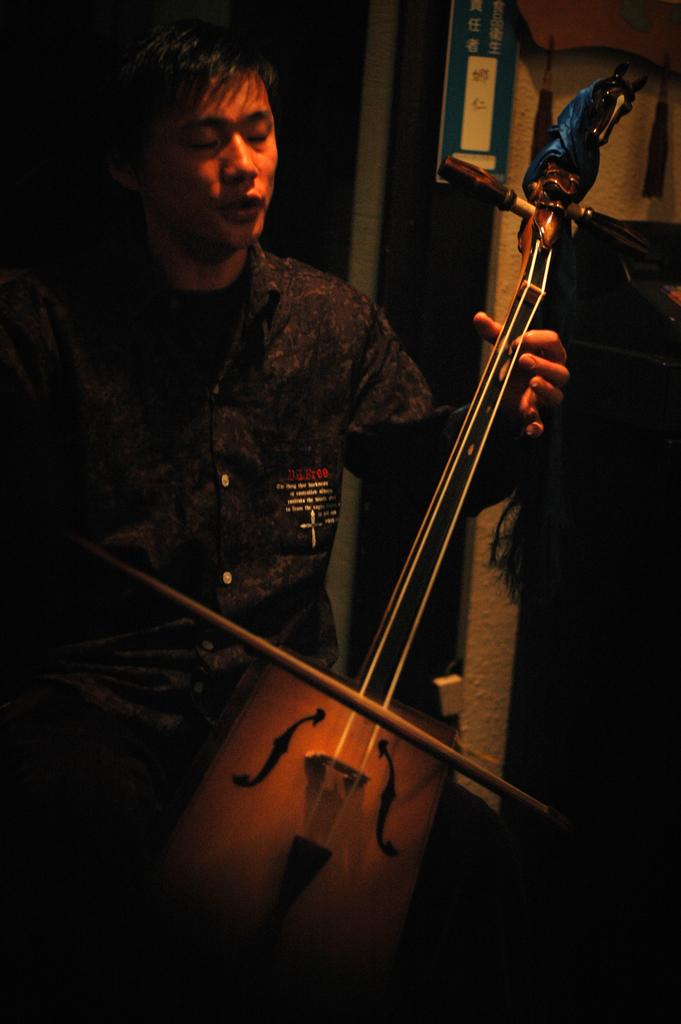What is the main activity being performed by the person in the image? The person in the image is playing a violin. What can be seen in the background of the image? There are posters and hangings in the background of the image. Can you describe the wooden shelf on the right side of the image? The wooden shelf is brown in color. What type of suit is the person wearing while playing the violin in the image? The image does not show the person wearing a suit; they are dressed in attire appropriate for playing the violin. What color paint is used on the posters and hangings in the background of the image? The image does not provide information about the color of paint used on the posters and hangings; it only shows their presence. 